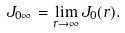<formula> <loc_0><loc_0><loc_500><loc_500>J _ { 0 \infty } = \lim _ { r \rightarrow \infty } J _ { 0 } ( r ) .</formula> 